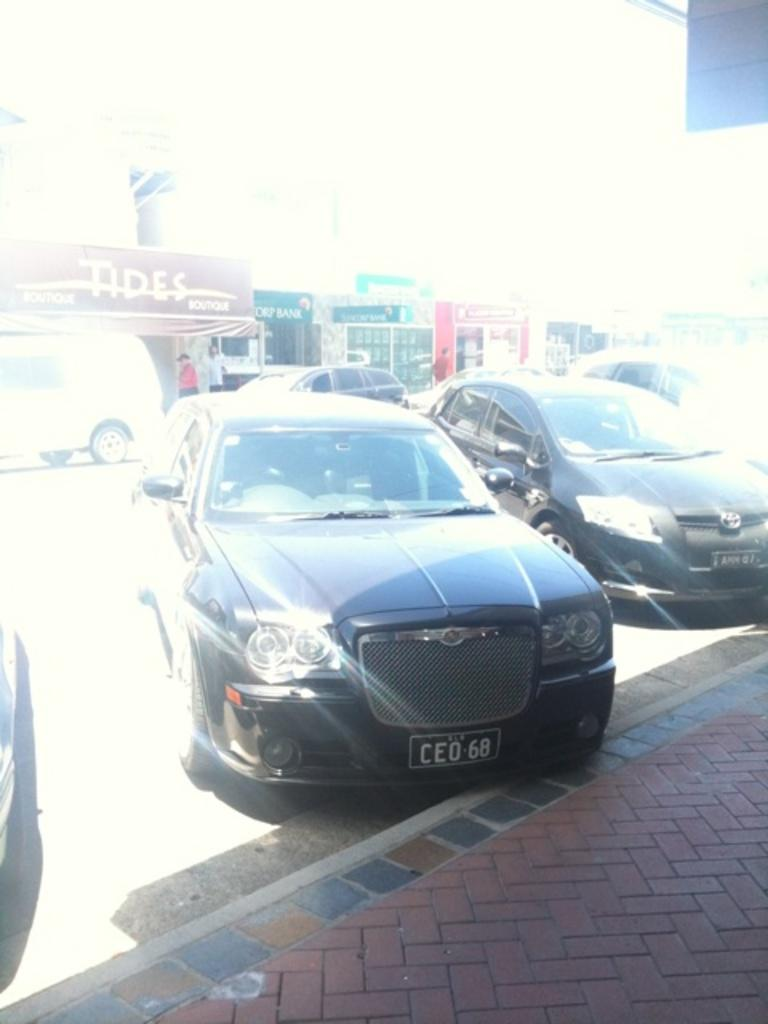What is the main subject of the image? The main subject of the image is the road, as it contains many vehicles. What else can be seen in the image besides the road? The image contains a footpath, a building, and people standing. What are the people in the image wearing? The people in the image are wearing clothes. Where is the nest located in the image? There is no nest present in the image. What type of hook can be seen in the image? There is no hook present in the image. 